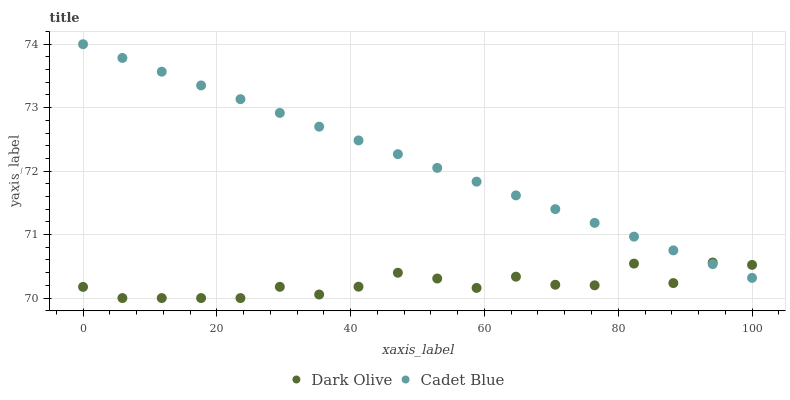Does Dark Olive have the minimum area under the curve?
Answer yes or no. Yes. Does Cadet Blue have the maximum area under the curve?
Answer yes or no. Yes. Does Dark Olive have the maximum area under the curve?
Answer yes or no. No. Is Cadet Blue the smoothest?
Answer yes or no. Yes. Is Dark Olive the roughest?
Answer yes or no. Yes. Is Dark Olive the smoothest?
Answer yes or no. No. Does Dark Olive have the lowest value?
Answer yes or no. Yes. Does Cadet Blue have the highest value?
Answer yes or no. Yes. Does Dark Olive have the highest value?
Answer yes or no. No. Does Dark Olive intersect Cadet Blue?
Answer yes or no. Yes. Is Dark Olive less than Cadet Blue?
Answer yes or no. No. Is Dark Olive greater than Cadet Blue?
Answer yes or no. No. 